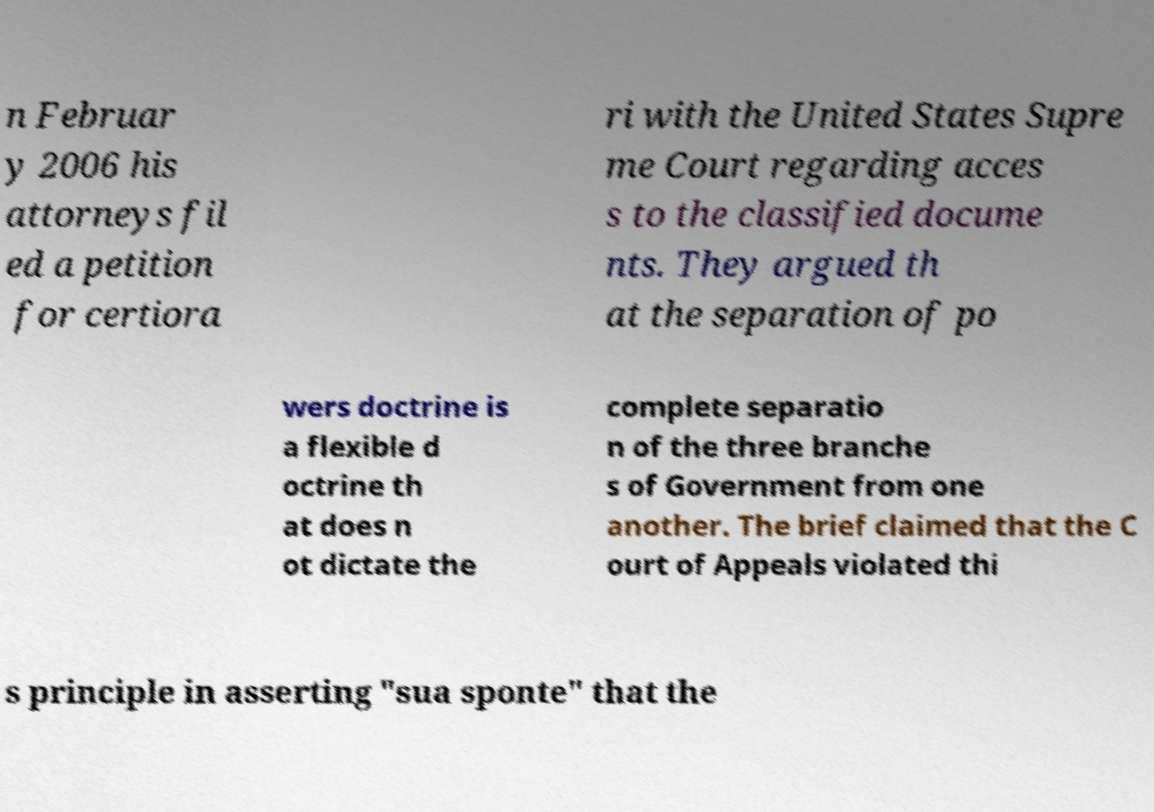Please read and relay the text visible in this image. What does it say? n Februar y 2006 his attorneys fil ed a petition for certiora ri with the United States Supre me Court regarding acces s to the classified docume nts. They argued th at the separation of po wers doctrine is a flexible d octrine th at does n ot dictate the complete separatio n of the three branche s of Government from one another. The brief claimed that the C ourt of Appeals violated thi s principle in asserting "sua sponte" that the 